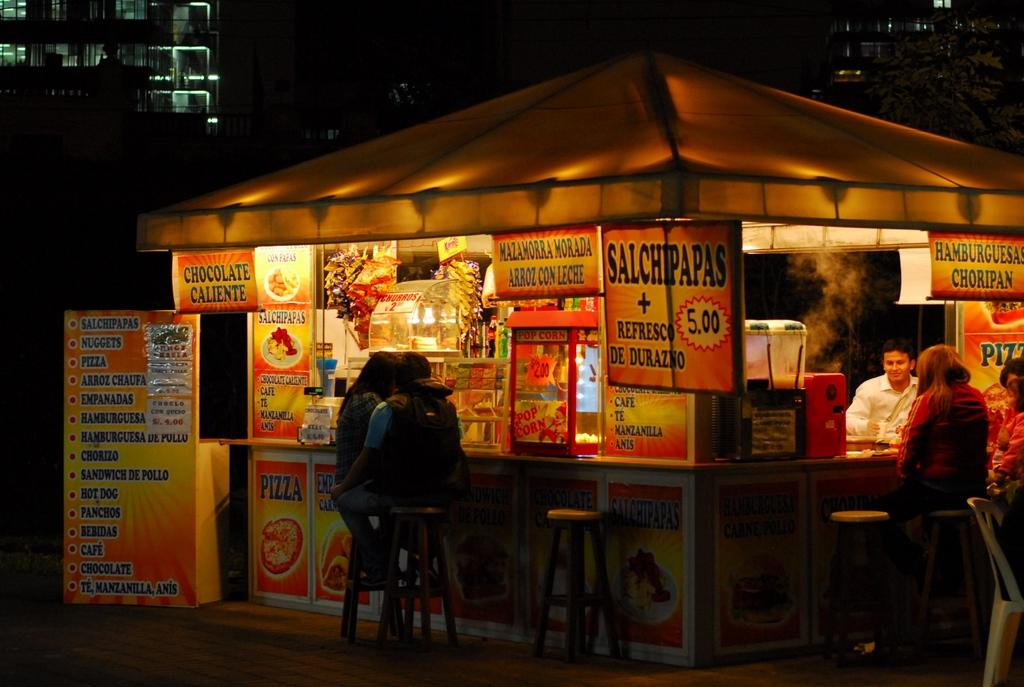What type of establishment is depicted in the image? There is a food court in the image. Can you describe the people present in the image? There are people in the food court. What are the people in the food court doing? The people in the food court are eating food items. Where is the jail located in the image? There is no jail present in the image. What type of spark can be seen coming from the food items in the image? There is no spark present in the image. Can you describe the cemetery visible in the background of the image? There is no cemetery visible in the image. 